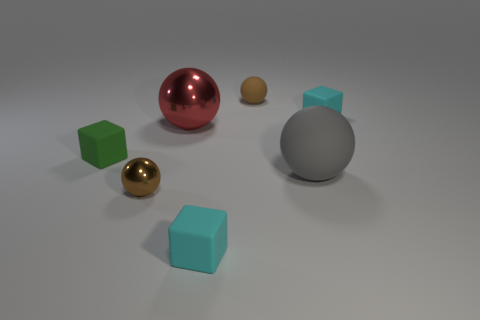Subtract all gray spheres. Subtract all blue cubes. How many spheres are left? 3 Add 2 big matte spheres. How many objects exist? 9 Subtract all cubes. How many objects are left? 4 Add 2 large gray rubber spheres. How many large gray rubber spheres exist? 3 Subtract 0 yellow blocks. How many objects are left? 7 Subtract all large cyan matte cylinders. Subtract all tiny cyan objects. How many objects are left? 5 Add 4 big shiny spheres. How many big shiny spheres are left? 5 